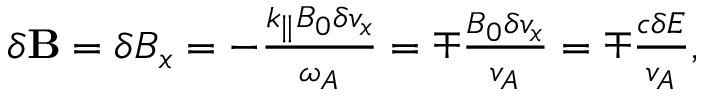Convert formula to latex. <formula><loc_0><loc_0><loc_500><loc_500>\begin{array} { r } { \delta B = \delta B _ { x } = - \frac { k _ { \| } B _ { 0 } \delta v _ { x } } { \omega _ { A } } = \mp \frac { B _ { 0 } \delta v _ { x } } { v _ { A } } = \mp \frac { c \delta E } { v _ { A } } , } \end{array}</formula> 